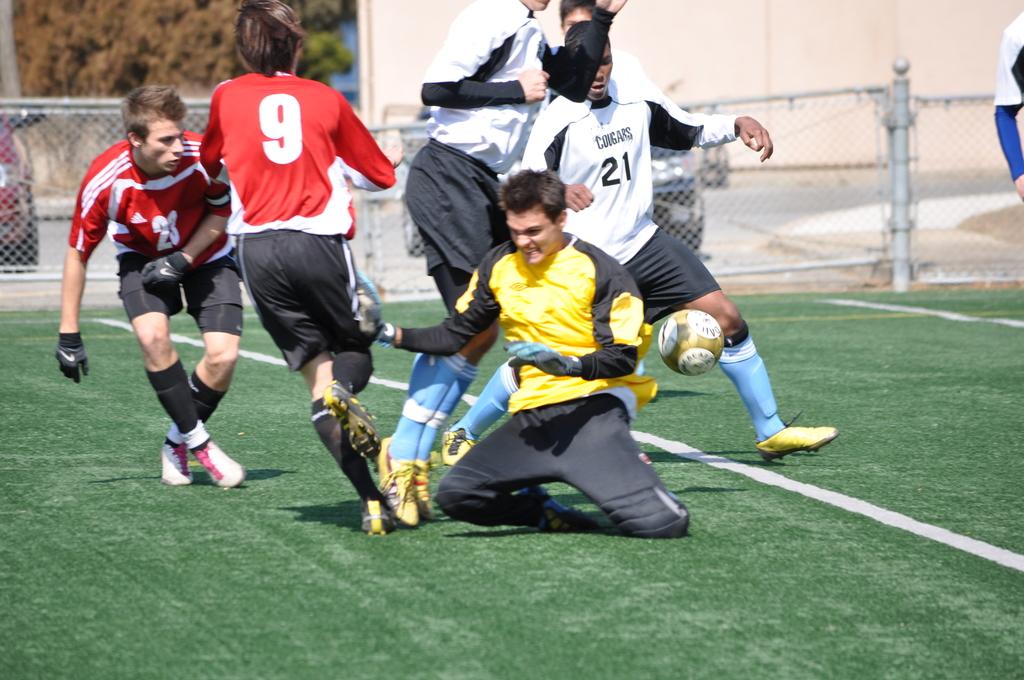Is number 21 on the field?
Give a very brief answer. Yes. What is the red players whos back is turned number?
Provide a succinct answer. 9. 